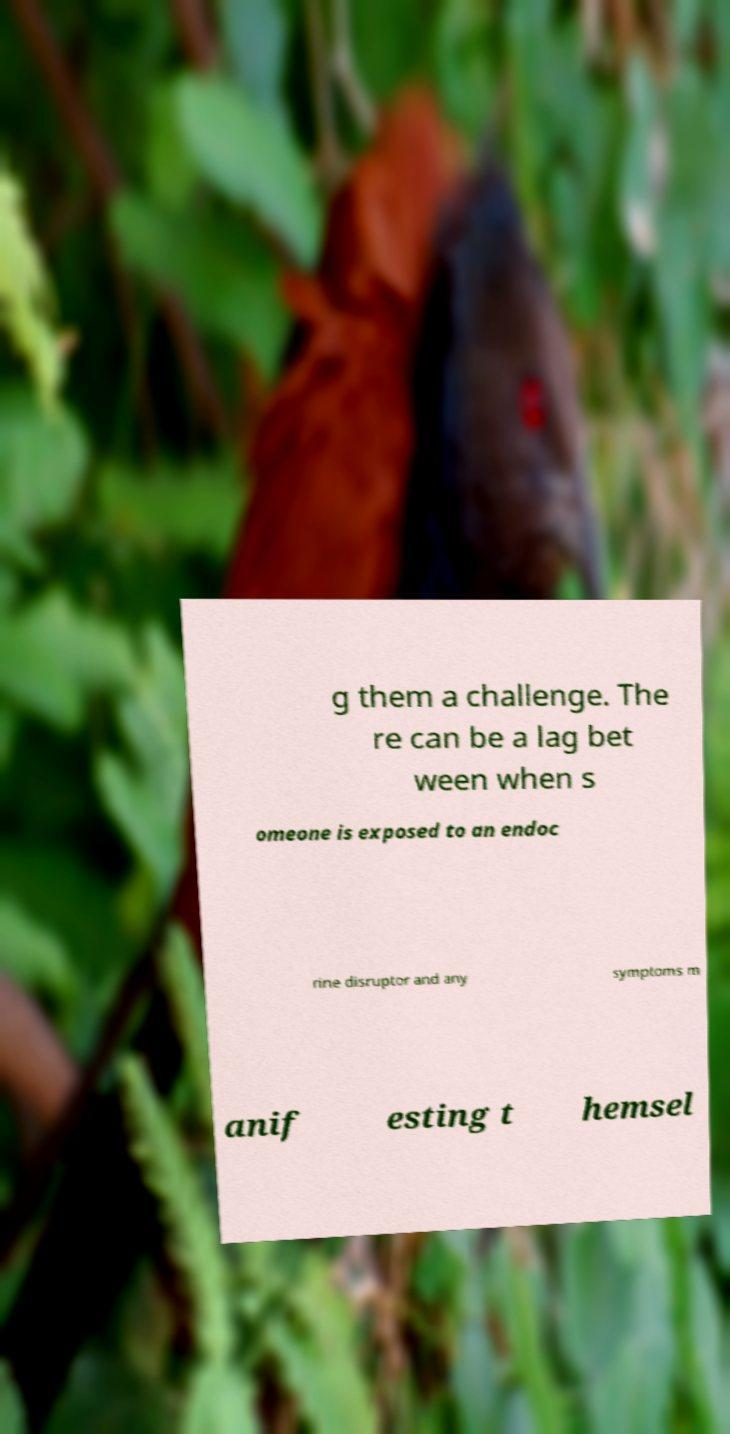Please identify and transcribe the text found in this image. g them a challenge. The re can be a lag bet ween when s omeone is exposed to an endoc rine disruptor and any symptoms m anif esting t hemsel 